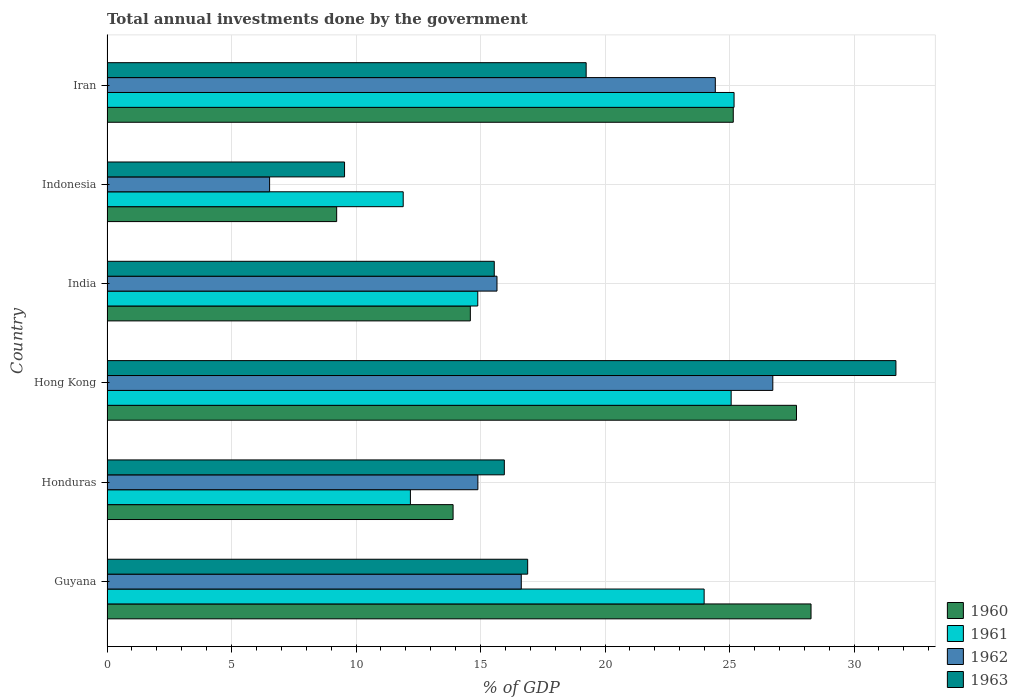How many different coloured bars are there?
Keep it short and to the point. 4. Are the number of bars per tick equal to the number of legend labels?
Offer a terse response. Yes. Are the number of bars on each tick of the Y-axis equal?
Provide a succinct answer. Yes. How many bars are there on the 5th tick from the top?
Ensure brevity in your answer.  4. What is the label of the 5th group of bars from the top?
Your response must be concise. Honduras. In how many cases, is the number of bars for a given country not equal to the number of legend labels?
Your answer should be very brief. 0. What is the total annual investments done by the government in 1960 in India?
Provide a succinct answer. 14.59. Across all countries, what is the maximum total annual investments done by the government in 1961?
Your answer should be very brief. 25.18. Across all countries, what is the minimum total annual investments done by the government in 1963?
Your answer should be compact. 9.54. In which country was the total annual investments done by the government in 1962 maximum?
Offer a terse response. Hong Kong. In which country was the total annual investments done by the government in 1961 minimum?
Make the answer very short. Indonesia. What is the total total annual investments done by the government in 1963 in the graph?
Your response must be concise. 108.86. What is the difference between the total annual investments done by the government in 1962 in Indonesia and that in Iran?
Ensure brevity in your answer.  -17.9. What is the difference between the total annual investments done by the government in 1960 in Hong Kong and the total annual investments done by the government in 1962 in Indonesia?
Ensure brevity in your answer.  21.16. What is the average total annual investments done by the government in 1962 per country?
Make the answer very short. 17.48. What is the difference between the total annual investments done by the government in 1960 and total annual investments done by the government in 1962 in Guyana?
Ensure brevity in your answer.  11.64. In how many countries, is the total annual investments done by the government in 1963 greater than 8 %?
Keep it short and to the point. 6. What is the ratio of the total annual investments done by the government in 1961 in India to that in Iran?
Your answer should be very brief. 0.59. Is the total annual investments done by the government in 1960 in Honduras less than that in Iran?
Keep it short and to the point. Yes. Is the difference between the total annual investments done by the government in 1960 in Hong Kong and India greater than the difference between the total annual investments done by the government in 1962 in Hong Kong and India?
Your response must be concise. Yes. What is the difference between the highest and the second highest total annual investments done by the government in 1963?
Ensure brevity in your answer.  12.44. What is the difference between the highest and the lowest total annual investments done by the government in 1961?
Your response must be concise. 13.29. In how many countries, is the total annual investments done by the government in 1963 greater than the average total annual investments done by the government in 1963 taken over all countries?
Your response must be concise. 2. Is it the case that in every country, the sum of the total annual investments done by the government in 1963 and total annual investments done by the government in 1962 is greater than the total annual investments done by the government in 1961?
Give a very brief answer. Yes. How many bars are there?
Offer a very short reply. 24. Are all the bars in the graph horizontal?
Give a very brief answer. Yes. Where does the legend appear in the graph?
Offer a very short reply. Bottom right. How are the legend labels stacked?
Give a very brief answer. Vertical. What is the title of the graph?
Offer a very short reply. Total annual investments done by the government. Does "1965" appear as one of the legend labels in the graph?
Offer a terse response. No. What is the label or title of the X-axis?
Provide a succinct answer. % of GDP. What is the % of GDP in 1960 in Guyana?
Offer a terse response. 28.27. What is the % of GDP in 1961 in Guyana?
Provide a short and direct response. 23.98. What is the % of GDP of 1962 in Guyana?
Keep it short and to the point. 16.64. What is the % of GDP of 1963 in Guyana?
Offer a terse response. 16.89. What is the % of GDP of 1960 in Honduras?
Provide a short and direct response. 13.9. What is the % of GDP of 1961 in Honduras?
Keep it short and to the point. 12.18. What is the % of GDP in 1962 in Honduras?
Offer a very short reply. 14.89. What is the % of GDP of 1963 in Honduras?
Give a very brief answer. 15.96. What is the % of GDP of 1960 in Hong Kong?
Give a very brief answer. 27.69. What is the % of GDP of 1961 in Hong Kong?
Ensure brevity in your answer.  25.06. What is the % of GDP of 1962 in Hong Kong?
Your answer should be compact. 26.74. What is the % of GDP in 1963 in Hong Kong?
Your answer should be very brief. 31.68. What is the % of GDP of 1960 in India?
Your answer should be very brief. 14.59. What is the % of GDP of 1961 in India?
Ensure brevity in your answer.  14.89. What is the % of GDP of 1962 in India?
Ensure brevity in your answer.  15.66. What is the % of GDP of 1963 in India?
Your answer should be compact. 15.55. What is the % of GDP in 1960 in Indonesia?
Your response must be concise. 9.22. What is the % of GDP of 1961 in Indonesia?
Your response must be concise. 11.9. What is the % of GDP of 1962 in Indonesia?
Give a very brief answer. 6.53. What is the % of GDP of 1963 in Indonesia?
Give a very brief answer. 9.54. What is the % of GDP in 1960 in Iran?
Provide a short and direct response. 25.15. What is the % of GDP in 1961 in Iran?
Your response must be concise. 25.18. What is the % of GDP of 1962 in Iran?
Provide a short and direct response. 24.43. What is the % of GDP in 1963 in Iran?
Ensure brevity in your answer.  19.24. Across all countries, what is the maximum % of GDP of 1960?
Keep it short and to the point. 28.27. Across all countries, what is the maximum % of GDP of 1961?
Your response must be concise. 25.18. Across all countries, what is the maximum % of GDP of 1962?
Your response must be concise. 26.74. Across all countries, what is the maximum % of GDP of 1963?
Provide a short and direct response. 31.68. Across all countries, what is the minimum % of GDP in 1960?
Keep it short and to the point. 9.22. Across all countries, what is the minimum % of GDP in 1961?
Ensure brevity in your answer.  11.9. Across all countries, what is the minimum % of GDP in 1962?
Give a very brief answer. 6.53. Across all countries, what is the minimum % of GDP in 1963?
Make the answer very short. 9.54. What is the total % of GDP of 1960 in the graph?
Keep it short and to the point. 118.82. What is the total % of GDP of 1961 in the graph?
Provide a short and direct response. 113.19. What is the total % of GDP in 1962 in the graph?
Provide a short and direct response. 104.89. What is the total % of GDP in 1963 in the graph?
Keep it short and to the point. 108.86. What is the difference between the % of GDP in 1960 in Guyana and that in Honduras?
Keep it short and to the point. 14.37. What is the difference between the % of GDP in 1961 in Guyana and that in Honduras?
Keep it short and to the point. 11.8. What is the difference between the % of GDP in 1962 in Guyana and that in Honduras?
Your answer should be very brief. 1.74. What is the difference between the % of GDP of 1963 in Guyana and that in Honduras?
Offer a terse response. 0.94. What is the difference between the % of GDP in 1960 in Guyana and that in Hong Kong?
Make the answer very short. 0.58. What is the difference between the % of GDP of 1961 in Guyana and that in Hong Kong?
Your answer should be compact. -1.08. What is the difference between the % of GDP of 1962 in Guyana and that in Hong Kong?
Ensure brevity in your answer.  -10.1. What is the difference between the % of GDP in 1963 in Guyana and that in Hong Kong?
Make the answer very short. -14.79. What is the difference between the % of GDP in 1960 in Guyana and that in India?
Offer a terse response. 13.68. What is the difference between the % of GDP in 1961 in Guyana and that in India?
Offer a very short reply. 9.09. What is the difference between the % of GDP in 1962 in Guyana and that in India?
Your answer should be compact. 0.98. What is the difference between the % of GDP of 1963 in Guyana and that in India?
Your response must be concise. 1.34. What is the difference between the % of GDP in 1960 in Guyana and that in Indonesia?
Your answer should be very brief. 19.05. What is the difference between the % of GDP in 1961 in Guyana and that in Indonesia?
Your answer should be compact. 12.08. What is the difference between the % of GDP in 1962 in Guyana and that in Indonesia?
Ensure brevity in your answer.  10.11. What is the difference between the % of GDP of 1963 in Guyana and that in Indonesia?
Give a very brief answer. 7.35. What is the difference between the % of GDP of 1960 in Guyana and that in Iran?
Keep it short and to the point. 3.12. What is the difference between the % of GDP of 1961 in Guyana and that in Iran?
Ensure brevity in your answer.  -1.2. What is the difference between the % of GDP of 1962 in Guyana and that in Iran?
Offer a terse response. -7.79. What is the difference between the % of GDP in 1963 in Guyana and that in Iran?
Your answer should be compact. -2.35. What is the difference between the % of GDP in 1960 in Honduras and that in Hong Kong?
Ensure brevity in your answer.  -13.79. What is the difference between the % of GDP in 1961 in Honduras and that in Hong Kong?
Make the answer very short. -12.88. What is the difference between the % of GDP in 1962 in Honduras and that in Hong Kong?
Offer a very short reply. -11.84. What is the difference between the % of GDP in 1963 in Honduras and that in Hong Kong?
Your response must be concise. -15.73. What is the difference between the % of GDP in 1960 in Honduras and that in India?
Provide a short and direct response. -0.69. What is the difference between the % of GDP in 1961 in Honduras and that in India?
Your answer should be very brief. -2.7. What is the difference between the % of GDP in 1962 in Honduras and that in India?
Your response must be concise. -0.77. What is the difference between the % of GDP in 1963 in Honduras and that in India?
Ensure brevity in your answer.  0.4. What is the difference between the % of GDP of 1960 in Honduras and that in Indonesia?
Give a very brief answer. 4.68. What is the difference between the % of GDP in 1961 in Honduras and that in Indonesia?
Keep it short and to the point. 0.29. What is the difference between the % of GDP in 1962 in Honduras and that in Indonesia?
Keep it short and to the point. 8.36. What is the difference between the % of GDP of 1963 in Honduras and that in Indonesia?
Make the answer very short. 6.42. What is the difference between the % of GDP in 1960 in Honduras and that in Iran?
Keep it short and to the point. -11.25. What is the difference between the % of GDP in 1961 in Honduras and that in Iran?
Make the answer very short. -13. What is the difference between the % of GDP in 1962 in Honduras and that in Iran?
Offer a terse response. -9.54. What is the difference between the % of GDP of 1963 in Honduras and that in Iran?
Offer a terse response. -3.29. What is the difference between the % of GDP of 1960 in Hong Kong and that in India?
Offer a terse response. 13.1. What is the difference between the % of GDP of 1961 in Hong Kong and that in India?
Provide a succinct answer. 10.18. What is the difference between the % of GDP of 1962 in Hong Kong and that in India?
Offer a terse response. 11.08. What is the difference between the % of GDP in 1963 in Hong Kong and that in India?
Your answer should be compact. 16.13. What is the difference between the % of GDP in 1960 in Hong Kong and that in Indonesia?
Your response must be concise. 18.47. What is the difference between the % of GDP of 1961 in Hong Kong and that in Indonesia?
Keep it short and to the point. 13.17. What is the difference between the % of GDP in 1962 in Hong Kong and that in Indonesia?
Your response must be concise. 20.21. What is the difference between the % of GDP in 1963 in Hong Kong and that in Indonesia?
Give a very brief answer. 22.14. What is the difference between the % of GDP of 1960 in Hong Kong and that in Iran?
Provide a short and direct response. 2.54. What is the difference between the % of GDP of 1961 in Hong Kong and that in Iran?
Provide a short and direct response. -0.12. What is the difference between the % of GDP of 1962 in Hong Kong and that in Iran?
Give a very brief answer. 2.31. What is the difference between the % of GDP of 1963 in Hong Kong and that in Iran?
Provide a short and direct response. 12.44. What is the difference between the % of GDP in 1960 in India and that in Indonesia?
Ensure brevity in your answer.  5.37. What is the difference between the % of GDP in 1961 in India and that in Indonesia?
Give a very brief answer. 2.99. What is the difference between the % of GDP of 1962 in India and that in Indonesia?
Offer a very short reply. 9.13. What is the difference between the % of GDP in 1963 in India and that in Indonesia?
Offer a terse response. 6.01. What is the difference between the % of GDP of 1960 in India and that in Iran?
Offer a terse response. -10.56. What is the difference between the % of GDP of 1961 in India and that in Iran?
Offer a very short reply. -10.29. What is the difference between the % of GDP of 1962 in India and that in Iran?
Provide a succinct answer. -8.77. What is the difference between the % of GDP in 1963 in India and that in Iran?
Make the answer very short. -3.69. What is the difference between the % of GDP of 1960 in Indonesia and that in Iran?
Your answer should be compact. -15.93. What is the difference between the % of GDP of 1961 in Indonesia and that in Iran?
Make the answer very short. -13.29. What is the difference between the % of GDP in 1962 in Indonesia and that in Iran?
Make the answer very short. -17.9. What is the difference between the % of GDP of 1963 in Indonesia and that in Iran?
Ensure brevity in your answer.  -9.7. What is the difference between the % of GDP in 1960 in Guyana and the % of GDP in 1961 in Honduras?
Offer a terse response. 16.09. What is the difference between the % of GDP of 1960 in Guyana and the % of GDP of 1962 in Honduras?
Offer a terse response. 13.38. What is the difference between the % of GDP in 1960 in Guyana and the % of GDP in 1963 in Honduras?
Your answer should be compact. 12.32. What is the difference between the % of GDP in 1961 in Guyana and the % of GDP in 1962 in Honduras?
Make the answer very short. 9.09. What is the difference between the % of GDP of 1961 in Guyana and the % of GDP of 1963 in Honduras?
Your answer should be very brief. 8.02. What is the difference between the % of GDP of 1962 in Guyana and the % of GDP of 1963 in Honduras?
Your answer should be very brief. 0.68. What is the difference between the % of GDP of 1960 in Guyana and the % of GDP of 1961 in Hong Kong?
Offer a terse response. 3.21. What is the difference between the % of GDP of 1960 in Guyana and the % of GDP of 1962 in Hong Kong?
Your answer should be very brief. 1.53. What is the difference between the % of GDP of 1960 in Guyana and the % of GDP of 1963 in Hong Kong?
Offer a very short reply. -3.41. What is the difference between the % of GDP of 1961 in Guyana and the % of GDP of 1962 in Hong Kong?
Give a very brief answer. -2.76. What is the difference between the % of GDP of 1961 in Guyana and the % of GDP of 1963 in Hong Kong?
Ensure brevity in your answer.  -7.7. What is the difference between the % of GDP of 1962 in Guyana and the % of GDP of 1963 in Hong Kong?
Ensure brevity in your answer.  -15.04. What is the difference between the % of GDP of 1960 in Guyana and the % of GDP of 1961 in India?
Provide a succinct answer. 13.38. What is the difference between the % of GDP of 1960 in Guyana and the % of GDP of 1962 in India?
Your response must be concise. 12.61. What is the difference between the % of GDP of 1960 in Guyana and the % of GDP of 1963 in India?
Make the answer very short. 12.72. What is the difference between the % of GDP in 1961 in Guyana and the % of GDP in 1962 in India?
Give a very brief answer. 8.32. What is the difference between the % of GDP of 1961 in Guyana and the % of GDP of 1963 in India?
Give a very brief answer. 8.43. What is the difference between the % of GDP in 1962 in Guyana and the % of GDP in 1963 in India?
Provide a succinct answer. 1.08. What is the difference between the % of GDP in 1960 in Guyana and the % of GDP in 1961 in Indonesia?
Provide a short and direct response. 16.38. What is the difference between the % of GDP of 1960 in Guyana and the % of GDP of 1962 in Indonesia?
Your response must be concise. 21.74. What is the difference between the % of GDP of 1960 in Guyana and the % of GDP of 1963 in Indonesia?
Your answer should be very brief. 18.73. What is the difference between the % of GDP of 1961 in Guyana and the % of GDP of 1962 in Indonesia?
Your answer should be very brief. 17.45. What is the difference between the % of GDP of 1961 in Guyana and the % of GDP of 1963 in Indonesia?
Provide a short and direct response. 14.44. What is the difference between the % of GDP in 1962 in Guyana and the % of GDP in 1963 in Indonesia?
Your response must be concise. 7.1. What is the difference between the % of GDP in 1960 in Guyana and the % of GDP in 1961 in Iran?
Offer a terse response. 3.09. What is the difference between the % of GDP of 1960 in Guyana and the % of GDP of 1962 in Iran?
Keep it short and to the point. 3.84. What is the difference between the % of GDP of 1960 in Guyana and the % of GDP of 1963 in Iran?
Keep it short and to the point. 9.03. What is the difference between the % of GDP of 1961 in Guyana and the % of GDP of 1962 in Iran?
Keep it short and to the point. -0.45. What is the difference between the % of GDP of 1961 in Guyana and the % of GDP of 1963 in Iran?
Offer a very short reply. 4.74. What is the difference between the % of GDP in 1962 in Guyana and the % of GDP in 1963 in Iran?
Make the answer very short. -2.61. What is the difference between the % of GDP of 1960 in Honduras and the % of GDP of 1961 in Hong Kong?
Provide a succinct answer. -11.17. What is the difference between the % of GDP in 1960 in Honduras and the % of GDP in 1962 in Hong Kong?
Make the answer very short. -12.84. What is the difference between the % of GDP of 1960 in Honduras and the % of GDP of 1963 in Hong Kong?
Give a very brief answer. -17.78. What is the difference between the % of GDP in 1961 in Honduras and the % of GDP in 1962 in Hong Kong?
Keep it short and to the point. -14.55. What is the difference between the % of GDP in 1961 in Honduras and the % of GDP in 1963 in Hong Kong?
Your answer should be very brief. -19.5. What is the difference between the % of GDP in 1962 in Honduras and the % of GDP in 1963 in Hong Kong?
Keep it short and to the point. -16.79. What is the difference between the % of GDP of 1960 in Honduras and the % of GDP of 1961 in India?
Keep it short and to the point. -0.99. What is the difference between the % of GDP in 1960 in Honduras and the % of GDP in 1962 in India?
Your answer should be very brief. -1.76. What is the difference between the % of GDP of 1960 in Honduras and the % of GDP of 1963 in India?
Offer a very short reply. -1.65. What is the difference between the % of GDP in 1961 in Honduras and the % of GDP in 1962 in India?
Give a very brief answer. -3.48. What is the difference between the % of GDP of 1961 in Honduras and the % of GDP of 1963 in India?
Make the answer very short. -3.37. What is the difference between the % of GDP of 1962 in Honduras and the % of GDP of 1963 in India?
Offer a very short reply. -0.66. What is the difference between the % of GDP in 1960 in Honduras and the % of GDP in 1961 in Indonesia?
Give a very brief answer. 2. What is the difference between the % of GDP of 1960 in Honduras and the % of GDP of 1962 in Indonesia?
Your answer should be very brief. 7.37. What is the difference between the % of GDP of 1960 in Honduras and the % of GDP of 1963 in Indonesia?
Give a very brief answer. 4.36. What is the difference between the % of GDP in 1961 in Honduras and the % of GDP in 1962 in Indonesia?
Your response must be concise. 5.65. What is the difference between the % of GDP of 1961 in Honduras and the % of GDP of 1963 in Indonesia?
Keep it short and to the point. 2.64. What is the difference between the % of GDP in 1962 in Honduras and the % of GDP in 1963 in Indonesia?
Give a very brief answer. 5.35. What is the difference between the % of GDP of 1960 in Honduras and the % of GDP of 1961 in Iran?
Provide a short and direct response. -11.28. What is the difference between the % of GDP of 1960 in Honduras and the % of GDP of 1962 in Iran?
Give a very brief answer. -10.53. What is the difference between the % of GDP in 1960 in Honduras and the % of GDP in 1963 in Iran?
Ensure brevity in your answer.  -5.34. What is the difference between the % of GDP of 1961 in Honduras and the % of GDP of 1962 in Iran?
Ensure brevity in your answer.  -12.24. What is the difference between the % of GDP of 1961 in Honduras and the % of GDP of 1963 in Iran?
Provide a short and direct response. -7.06. What is the difference between the % of GDP in 1962 in Honduras and the % of GDP in 1963 in Iran?
Your answer should be very brief. -4.35. What is the difference between the % of GDP of 1960 in Hong Kong and the % of GDP of 1961 in India?
Offer a very short reply. 12.8. What is the difference between the % of GDP in 1960 in Hong Kong and the % of GDP in 1962 in India?
Your answer should be compact. 12.03. What is the difference between the % of GDP in 1960 in Hong Kong and the % of GDP in 1963 in India?
Your answer should be very brief. 12.14. What is the difference between the % of GDP in 1961 in Hong Kong and the % of GDP in 1962 in India?
Your answer should be compact. 9.4. What is the difference between the % of GDP in 1961 in Hong Kong and the % of GDP in 1963 in India?
Give a very brief answer. 9.51. What is the difference between the % of GDP in 1962 in Hong Kong and the % of GDP in 1963 in India?
Provide a short and direct response. 11.19. What is the difference between the % of GDP in 1960 in Hong Kong and the % of GDP in 1961 in Indonesia?
Ensure brevity in your answer.  15.79. What is the difference between the % of GDP of 1960 in Hong Kong and the % of GDP of 1962 in Indonesia?
Offer a terse response. 21.16. What is the difference between the % of GDP of 1960 in Hong Kong and the % of GDP of 1963 in Indonesia?
Offer a terse response. 18.15. What is the difference between the % of GDP in 1961 in Hong Kong and the % of GDP in 1962 in Indonesia?
Offer a very short reply. 18.54. What is the difference between the % of GDP in 1961 in Hong Kong and the % of GDP in 1963 in Indonesia?
Offer a terse response. 15.53. What is the difference between the % of GDP in 1962 in Hong Kong and the % of GDP in 1963 in Indonesia?
Your answer should be compact. 17.2. What is the difference between the % of GDP of 1960 in Hong Kong and the % of GDP of 1961 in Iran?
Your answer should be compact. 2.51. What is the difference between the % of GDP of 1960 in Hong Kong and the % of GDP of 1962 in Iran?
Make the answer very short. 3.26. What is the difference between the % of GDP in 1960 in Hong Kong and the % of GDP in 1963 in Iran?
Offer a terse response. 8.45. What is the difference between the % of GDP in 1961 in Hong Kong and the % of GDP in 1962 in Iran?
Your answer should be very brief. 0.64. What is the difference between the % of GDP of 1961 in Hong Kong and the % of GDP of 1963 in Iran?
Your response must be concise. 5.82. What is the difference between the % of GDP in 1962 in Hong Kong and the % of GDP in 1963 in Iran?
Provide a short and direct response. 7.5. What is the difference between the % of GDP of 1960 in India and the % of GDP of 1961 in Indonesia?
Give a very brief answer. 2.7. What is the difference between the % of GDP of 1960 in India and the % of GDP of 1962 in Indonesia?
Your response must be concise. 8.06. What is the difference between the % of GDP in 1960 in India and the % of GDP in 1963 in Indonesia?
Give a very brief answer. 5.05. What is the difference between the % of GDP in 1961 in India and the % of GDP in 1962 in Indonesia?
Provide a succinct answer. 8.36. What is the difference between the % of GDP in 1961 in India and the % of GDP in 1963 in Indonesia?
Provide a succinct answer. 5.35. What is the difference between the % of GDP of 1962 in India and the % of GDP of 1963 in Indonesia?
Offer a terse response. 6.12. What is the difference between the % of GDP of 1960 in India and the % of GDP of 1961 in Iran?
Provide a short and direct response. -10.59. What is the difference between the % of GDP in 1960 in India and the % of GDP in 1962 in Iran?
Your response must be concise. -9.84. What is the difference between the % of GDP in 1960 in India and the % of GDP in 1963 in Iran?
Give a very brief answer. -4.65. What is the difference between the % of GDP of 1961 in India and the % of GDP of 1962 in Iran?
Offer a terse response. -9.54. What is the difference between the % of GDP of 1961 in India and the % of GDP of 1963 in Iran?
Ensure brevity in your answer.  -4.35. What is the difference between the % of GDP of 1962 in India and the % of GDP of 1963 in Iran?
Ensure brevity in your answer.  -3.58. What is the difference between the % of GDP of 1960 in Indonesia and the % of GDP of 1961 in Iran?
Make the answer very short. -15.96. What is the difference between the % of GDP of 1960 in Indonesia and the % of GDP of 1962 in Iran?
Provide a short and direct response. -15.21. What is the difference between the % of GDP of 1960 in Indonesia and the % of GDP of 1963 in Iran?
Offer a terse response. -10.02. What is the difference between the % of GDP of 1961 in Indonesia and the % of GDP of 1962 in Iran?
Your response must be concise. -12.53. What is the difference between the % of GDP of 1961 in Indonesia and the % of GDP of 1963 in Iran?
Your answer should be very brief. -7.35. What is the difference between the % of GDP in 1962 in Indonesia and the % of GDP in 1963 in Iran?
Your answer should be compact. -12.71. What is the average % of GDP of 1960 per country?
Keep it short and to the point. 19.8. What is the average % of GDP in 1961 per country?
Provide a succinct answer. 18.87. What is the average % of GDP in 1962 per country?
Ensure brevity in your answer.  17.48. What is the average % of GDP in 1963 per country?
Provide a succinct answer. 18.14. What is the difference between the % of GDP of 1960 and % of GDP of 1961 in Guyana?
Give a very brief answer. 4.29. What is the difference between the % of GDP in 1960 and % of GDP in 1962 in Guyana?
Make the answer very short. 11.64. What is the difference between the % of GDP of 1960 and % of GDP of 1963 in Guyana?
Provide a short and direct response. 11.38. What is the difference between the % of GDP of 1961 and % of GDP of 1962 in Guyana?
Ensure brevity in your answer.  7.34. What is the difference between the % of GDP of 1961 and % of GDP of 1963 in Guyana?
Your answer should be compact. 7.09. What is the difference between the % of GDP of 1962 and % of GDP of 1963 in Guyana?
Provide a succinct answer. -0.26. What is the difference between the % of GDP in 1960 and % of GDP in 1961 in Honduras?
Offer a very short reply. 1.71. What is the difference between the % of GDP in 1960 and % of GDP in 1962 in Honduras?
Keep it short and to the point. -1. What is the difference between the % of GDP in 1960 and % of GDP in 1963 in Honduras?
Your answer should be compact. -2.06. What is the difference between the % of GDP of 1961 and % of GDP of 1962 in Honduras?
Offer a terse response. -2.71. What is the difference between the % of GDP of 1961 and % of GDP of 1963 in Honduras?
Provide a succinct answer. -3.77. What is the difference between the % of GDP in 1962 and % of GDP in 1963 in Honduras?
Ensure brevity in your answer.  -1.06. What is the difference between the % of GDP of 1960 and % of GDP of 1961 in Hong Kong?
Make the answer very short. 2.62. What is the difference between the % of GDP in 1960 and % of GDP in 1962 in Hong Kong?
Make the answer very short. 0.95. What is the difference between the % of GDP in 1960 and % of GDP in 1963 in Hong Kong?
Your answer should be very brief. -3.99. What is the difference between the % of GDP of 1961 and % of GDP of 1962 in Hong Kong?
Keep it short and to the point. -1.67. What is the difference between the % of GDP of 1961 and % of GDP of 1963 in Hong Kong?
Keep it short and to the point. -6.62. What is the difference between the % of GDP in 1962 and % of GDP in 1963 in Hong Kong?
Provide a succinct answer. -4.94. What is the difference between the % of GDP of 1960 and % of GDP of 1961 in India?
Give a very brief answer. -0.3. What is the difference between the % of GDP in 1960 and % of GDP in 1962 in India?
Ensure brevity in your answer.  -1.07. What is the difference between the % of GDP in 1960 and % of GDP in 1963 in India?
Provide a succinct answer. -0.96. What is the difference between the % of GDP in 1961 and % of GDP in 1962 in India?
Provide a succinct answer. -0.77. What is the difference between the % of GDP in 1961 and % of GDP in 1963 in India?
Provide a succinct answer. -0.66. What is the difference between the % of GDP in 1962 and % of GDP in 1963 in India?
Offer a very short reply. 0.11. What is the difference between the % of GDP in 1960 and % of GDP in 1961 in Indonesia?
Your response must be concise. -2.67. What is the difference between the % of GDP in 1960 and % of GDP in 1962 in Indonesia?
Your answer should be compact. 2.69. What is the difference between the % of GDP of 1960 and % of GDP of 1963 in Indonesia?
Your answer should be compact. -0.32. What is the difference between the % of GDP in 1961 and % of GDP in 1962 in Indonesia?
Your answer should be compact. 5.37. What is the difference between the % of GDP in 1961 and % of GDP in 1963 in Indonesia?
Give a very brief answer. 2.36. What is the difference between the % of GDP in 1962 and % of GDP in 1963 in Indonesia?
Your answer should be compact. -3.01. What is the difference between the % of GDP in 1960 and % of GDP in 1961 in Iran?
Make the answer very short. -0.03. What is the difference between the % of GDP in 1960 and % of GDP in 1962 in Iran?
Give a very brief answer. 0.72. What is the difference between the % of GDP in 1960 and % of GDP in 1963 in Iran?
Offer a terse response. 5.91. What is the difference between the % of GDP in 1961 and % of GDP in 1962 in Iran?
Your answer should be compact. 0.75. What is the difference between the % of GDP of 1961 and % of GDP of 1963 in Iran?
Keep it short and to the point. 5.94. What is the difference between the % of GDP in 1962 and % of GDP in 1963 in Iran?
Make the answer very short. 5.19. What is the ratio of the % of GDP of 1960 in Guyana to that in Honduras?
Ensure brevity in your answer.  2.03. What is the ratio of the % of GDP in 1961 in Guyana to that in Honduras?
Your answer should be compact. 1.97. What is the ratio of the % of GDP in 1962 in Guyana to that in Honduras?
Provide a short and direct response. 1.12. What is the ratio of the % of GDP in 1963 in Guyana to that in Honduras?
Give a very brief answer. 1.06. What is the ratio of the % of GDP of 1960 in Guyana to that in Hong Kong?
Your response must be concise. 1.02. What is the ratio of the % of GDP of 1961 in Guyana to that in Hong Kong?
Offer a terse response. 0.96. What is the ratio of the % of GDP of 1962 in Guyana to that in Hong Kong?
Offer a terse response. 0.62. What is the ratio of the % of GDP of 1963 in Guyana to that in Hong Kong?
Keep it short and to the point. 0.53. What is the ratio of the % of GDP in 1960 in Guyana to that in India?
Ensure brevity in your answer.  1.94. What is the ratio of the % of GDP of 1961 in Guyana to that in India?
Provide a succinct answer. 1.61. What is the ratio of the % of GDP of 1962 in Guyana to that in India?
Make the answer very short. 1.06. What is the ratio of the % of GDP of 1963 in Guyana to that in India?
Keep it short and to the point. 1.09. What is the ratio of the % of GDP in 1960 in Guyana to that in Indonesia?
Offer a very short reply. 3.07. What is the ratio of the % of GDP of 1961 in Guyana to that in Indonesia?
Give a very brief answer. 2.02. What is the ratio of the % of GDP of 1962 in Guyana to that in Indonesia?
Your answer should be compact. 2.55. What is the ratio of the % of GDP in 1963 in Guyana to that in Indonesia?
Keep it short and to the point. 1.77. What is the ratio of the % of GDP of 1960 in Guyana to that in Iran?
Offer a terse response. 1.12. What is the ratio of the % of GDP in 1961 in Guyana to that in Iran?
Keep it short and to the point. 0.95. What is the ratio of the % of GDP in 1962 in Guyana to that in Iran?
Keep it short and to the point. 0.68. What is the ratio of the % of GDP of 1963 in Guyana to that in Iran?
Ensure brevity in your answer.  0.88. What is the ratio of the % of GDP in 1960 in Honduras to that in Hong Kong?
Keep it short and to the point. 0.5. What is the ratio of the % of GDP in 1961 in Honduras to that in Hong Kong?
Your response must be concise. 0.49. What is the ratio of the % of GDP of 1962 in Honduras to that in Hong Kong?
Provide a succinct answer. 0.56. What is the ratio of the % of GDP of 1963 in Honduras to that in Hong Kong?
Your answer should be very brief. 0.5. What is the ratio of the % of GDP of 1960 in Honduras to that in India?
Give a very brief answer. 0.95. What is the ratio of the % of GDP in 1961 in Honduras to that in India?
Your response must be concise. 0.82. What is the ratio of the % of GDP of 1962 in Honduras to that in India?
Give a very brief answer. 0.95. What is the ratio of the % of GDP in 1960 in Honduras to that in Indonesia?
Keep it short and to the point. 1.51. What is the ratio of the % of GDP of 1961 in Honduras to that in Indonesia?
Provide a short and direct response. 1.02. What is the ratio of the % of GDP in 1962 in Honduras to that in Indonesia?
Make the answer very short. 2.28. What is the ratio of the % of GDP of 1963 in Honduras to that in Indonesia?
Your answer should be compact. 1.67. What is the ratio of the % of GDP in 1960 in Honduras to that in Iran?
Make the answer very short. 0.55. What is the ratio of the % of GDP in 1961 in Honduras to that in Iran?
Offer a very short reply. 0.48. What is the ratio of the % of GDP of 1962 in Honduras to that in Iran?
Give a very brief answer. 0.61. What is the ratio of the % of GDP of 1963 in Honduras to that in Iran?
Ensure brevity in your answer.  0.83. What is the ratio of the % of GDP in 1960 in Hong Kong to that in India?
Give a very brief answer. 1.9. What is the ratio of the % of GDP of 1961 in Hong Kong to that in India?
Offer a very short reply. 1.68. What is the ratio of the % of GDP in 1962 in Hong Kong to that in India?
Give a very brief answer. 1.71. What is the ratio of the % of GDP of 1963 in Hong Kong to that in India?
Provide a succinct answer. 2.04. What is the ratio of the % of GDP in 1960 in Hong Kong to that in Indonesia?
Your answer should be compact. 3. What is the ratio of the % of GDP in 1961 in Hong Kong to that in Indonesia?
Your answer should be very brief. 2.11. What is the ratio of the % of GDP in 1962 in Hong Kong to that in Indonesia?
Provide a succinct answer. 4.09. What is the ratio of the % of GDP in 1963 in Hong Kong to that in Indonesia?
Keep it short and to the point. 3.32. What is the ratio of the % of GDP of 1960 in Hong Kong to that in Iran?
Keep it short and to the point. 1.1. What is the ratio of the % of GDP of 1961 in Hong Kong to that in Iran?
Offer a very short reply. 1. What is the ratio of the % of GDP of 1962 in Hong Kong to that in Iran?
Offer a terse response. 1.09. What is the ratio of the % of GDP in 1963 in Hong Kong to that in Iran?
Your answer should be very brief. 1.65. What is the ratio of the % of GDP of 1960 in India to that in Indonesia?
Your answer should be compact. 1.58. What is the ratio of the % of GDP of 1961 in India to that in Indonesia?
Provide a succinct answer. 1.25. What is the ratio of the % of GDP in 1962 in India to that in Indonesia?
Provide a short and direct response. 2.4. What is the ratio of the % of GDP in 1963 in India to that in Indonesia?
Your answer should be very brief. 1.63. What is the ratio of the % of GDP of 1960 in India to that in Iran?
Offer a terse response. 0.58. What is the ratio of the % of GDP in 1961 in India to that in Iran?
Your answer should be compact. 0.59. What is the ratio of the % of GDP in 1962 in India to that in Iran?
Make the answer very short. 0.64. What is the ratio of the % of GDP of 1963 in India to that in Iran?
Provide a succinct answer. 0.81. What is the ratio of the % of GDP in 1960 in Indonesia to that in Iran?
Your answer should be very brief. 0.37. What is the ratio of the % of GDP of 1961 in Indonesia to that in Iran?
Offer a terse response. 0.47. What is the ratio of the % of GDP in 1962 in Indonesia to that in Iran?
Keep it short and to the point. 0.27. What is the ratio of the % of GDP of 1963 in Indonesia to that in Iran?
Give a very brief answer. 0.5. What is the difference between the highest and the second highest % of GDP in 1960?
Ensure brevity in your answer.  0.58. What is the difference between the highest and the second highest % of GDP in 1961?
Your answer should be compact. 0.12. What is the difference between the highest and the second highest % of GDP of 1962?
Keep it short and to the point. 2.31. What is the difference between the highest and the second highest % of GDP in 1963?
Offer a terse response. 12.44. What is the difference between the highest and the lowest % of GDP of 1960?
Keep it short and to the point. 19.05. What is the difference between the highest and the lowest % of GDP of 1961?
Your answer should be compact. 13.29. What is the difference between the highest and the lowest % of GDP in 1962?
Offer a very short reply. 20.21. What is the difference between the highest and the lowest % of GDP in 1963?
Give a very brief answer. 22.14. 